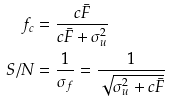Convert formula to latex. <formula><loc_0><loc_0><loc_500><loc_500>f _ { c } & = \frac { c \bar { F } } { c \bar { F } + \sigma _ { u } ^ { 2 } } \\ S / N & = \frac { 1 } { \sigma _ { f } } = \frac { 1 } { \sqrt { \sigma _ { u } ^ { 2 } + c \bar { F } } }</formula> 